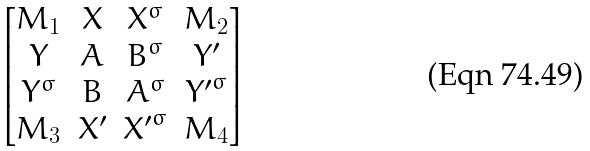Convert formula to latex. <formula><loc_0><loc_0><loc_500><loc_500>\begin{bmatrix} M _ { 1 } & X & X ^ { \sigma } & M _ { 2 } \\ Y & A & B ^ { \sigma } & Y ^ { \prime } \\ Y ^ { \sigma } & B & A ^ { \sigma } & { Y ^ { \prime } } ^ { \sigma } \\ M _ { 3 } & X ^ { \prime } & { X ^ { \prime } } ^ { \sigma } & M _ { 4 } \end{bmatrix}</formula> 